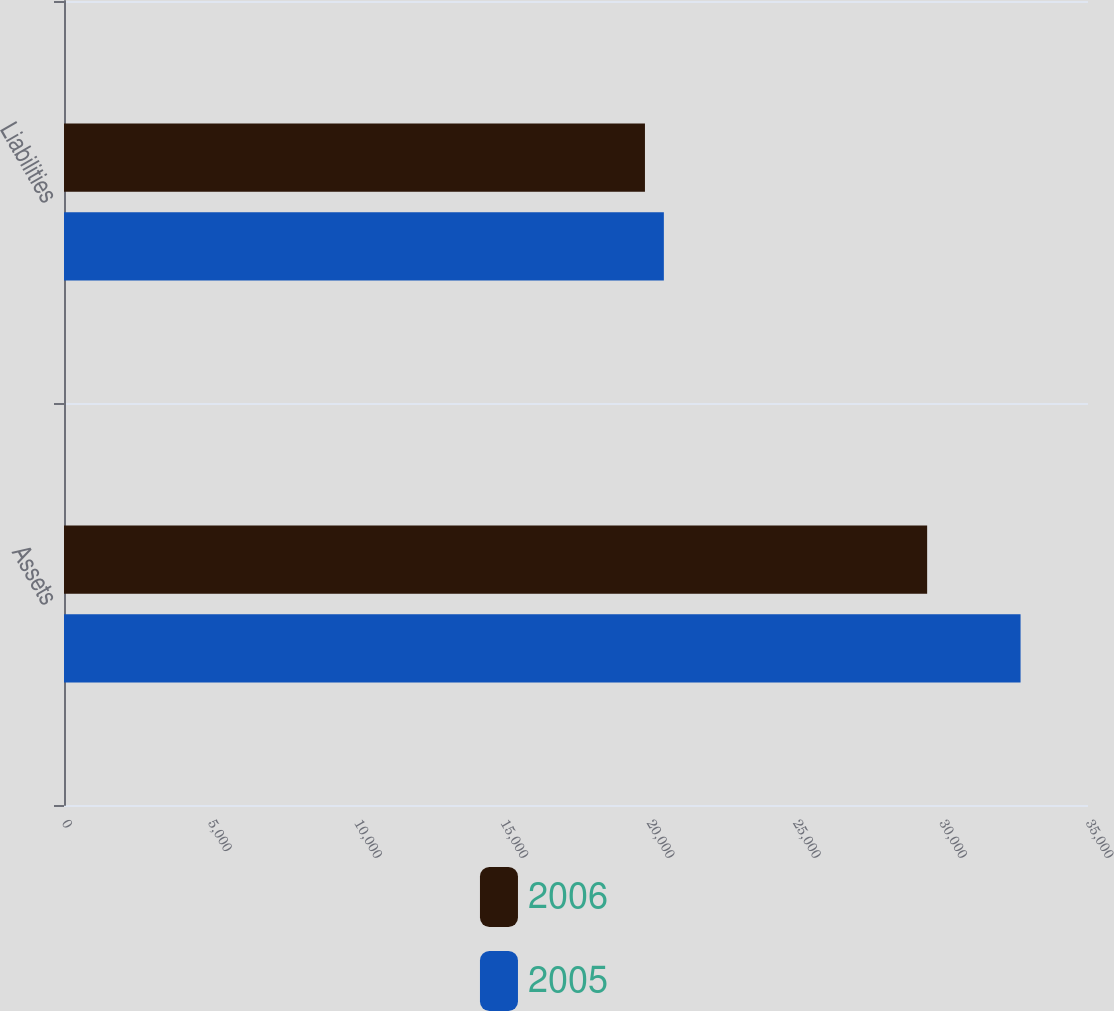Convert chart to OTSL. <chart><loc_0><loc_0><loc_500><loc_500><stacked_bar_chart><ecel><fcel>Assets<fcel>Liabilities<nl><fcel>2006<fcel>29502<fcel>19857<nl><fcel>2005<fcel>32695<fcel>20503<nl></chart> 